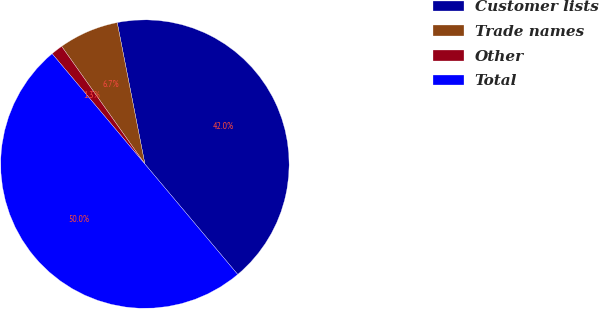<chart> <loc_0><loc_0><loc_500><loc_500><pie_chart><fcel>Customer lists<fcel>Trade names<fcel>Other<fcel>Total<nl><fcel>41.95%<fcel>6.72%<fcel>1.33%<fcel>50.0%<nl></chart> 